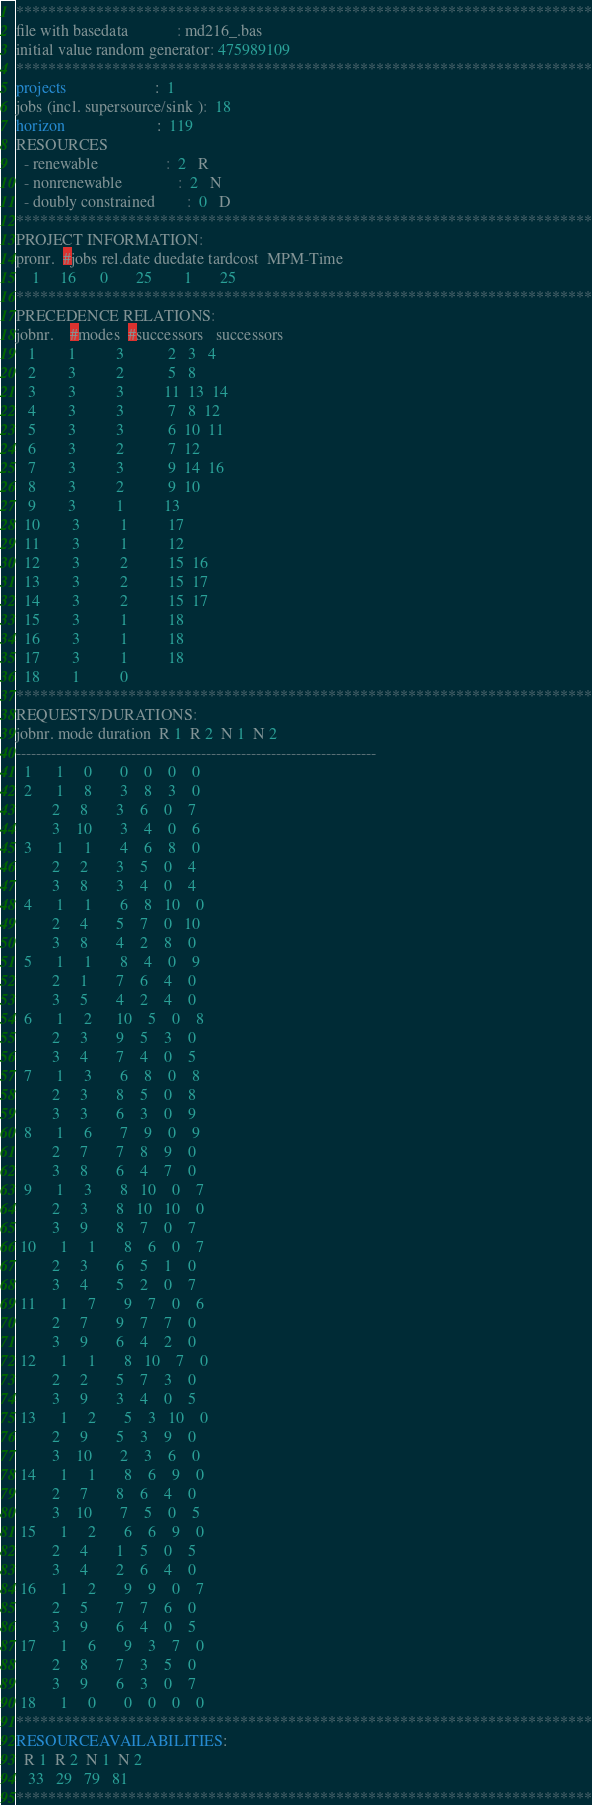<code> <loc_0><loc_0><loc_500><loc_500><_ObjectiveC_>************************************************************************
file with basedata            : md216_.bas
initial value random generator: 475989109
************************************************************************
projects                      :  1
jobs (incl. supersource/sink ):  18
horizon                       :  119
RESOURCES
  - renewable                 :  2   R
  - nonrenewable              :  2   N
  - doubly constrained        :  0   D
************************************************************************
PROJECT INFORMATION:
pronr.  #jobs rel.date duedate tardcost  MPM-Time
    1     16      0       25        1       25
************************************************************************
PRECEDENCE RELATIONS:
jobnr.    #modes  #successors   successors
   1        1          3           2   3   4
   2        3          2           5   8
   3        3          3          11  13  14
   4        3          3           7   8  12
   5        3          3           6  10  11
   6        3          2           7  12
   7        3          3           9  14  16
   8        3          2           9  10
   9        3          1          13
  10        3          1          17
  11        3          1          12
  12        3          2          15  16
  13        3          2          15  17
  14        3          2          15  17
  15        3          1          18
  16        3          1          18
  17        3          1          18
  18        1          0        
************************************************************************
REQUESTS/DURATIONS:
jobnr. mode duration  R 1  R 2  N 1  N 2
------------------------------------------------------------------------
  1      1     0       0    0    0    0
  2      1     8       3    8    3    0
         2     8       3    6    0    7
         3    10       3    4    0    6
  3      1     1       4    6    8    0
         2     2       3    5    0    4
         3     8       3    4    0    4
  4      1     1       6    8   10    0
         2     4       5    7    0   10
         3     8       4    2    8    0
  5      1     1       8    4    0    9
         2     1       7    6    4    0
         3     5       4    2    4    0
  6      1     2      10    5    0    8
         2     3       9    5    3    0
         3     4       7    4    0    5
  7      1     3       6    8    0    8
         2     3       8    5    0    8
         3     3       6    3    0    9
  8      1     6       7    9    0    9
         2     7       7    8    9    0
         3     8       6    4    7    0
  9      1     3       8   10    0    7
         2     3       8   10   10    0
         3     9       8    7    0    7
 10      1     1       8    6    0    7
         2     3       6    5    1    0
         3     4       5    2    0    7
 11      1     7       9    7    0    6
         2     7       9    7    7    0
         3     9       6    4    2    0
 12      1     1       8   10    7    0
         2     2       5    7    3    0
         3     9       3    4    0    5
 13      1     2       5    3   10    0
         2     9       5    3    9    0
         3    10       2    3    6    0
 14      1     1       8    6    9    0
         2     7       8    6    4    0
         3    10       7    5    0    5
 15      1     2       6    6    9    0
         2     4       1    5    0    5
         3     4       2    6    4    0
 16      1     2       9    9    0    7
         2     5       7    7    6    0
         3     9       6    4    0    5
 17      1     6       9    3    7    0
         2     8       7    3    5    0
         3     9       6    3    0    7
 18      1     0       0    0    0    0
************************************************************************
RESOURCEAVAILABILITIES:
  R 1  R 2  N 1  N 2
   33   29   79   81
************************************************************************
</code> 